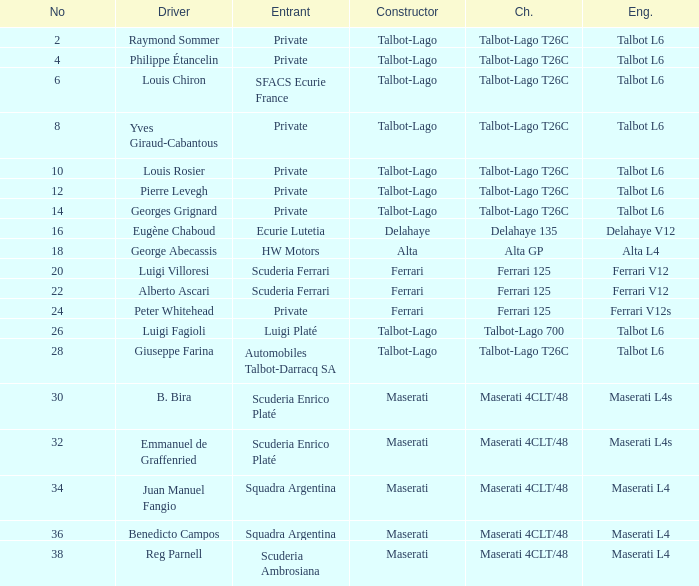Name the engine for ecurie lutetia Delahaye V12. 